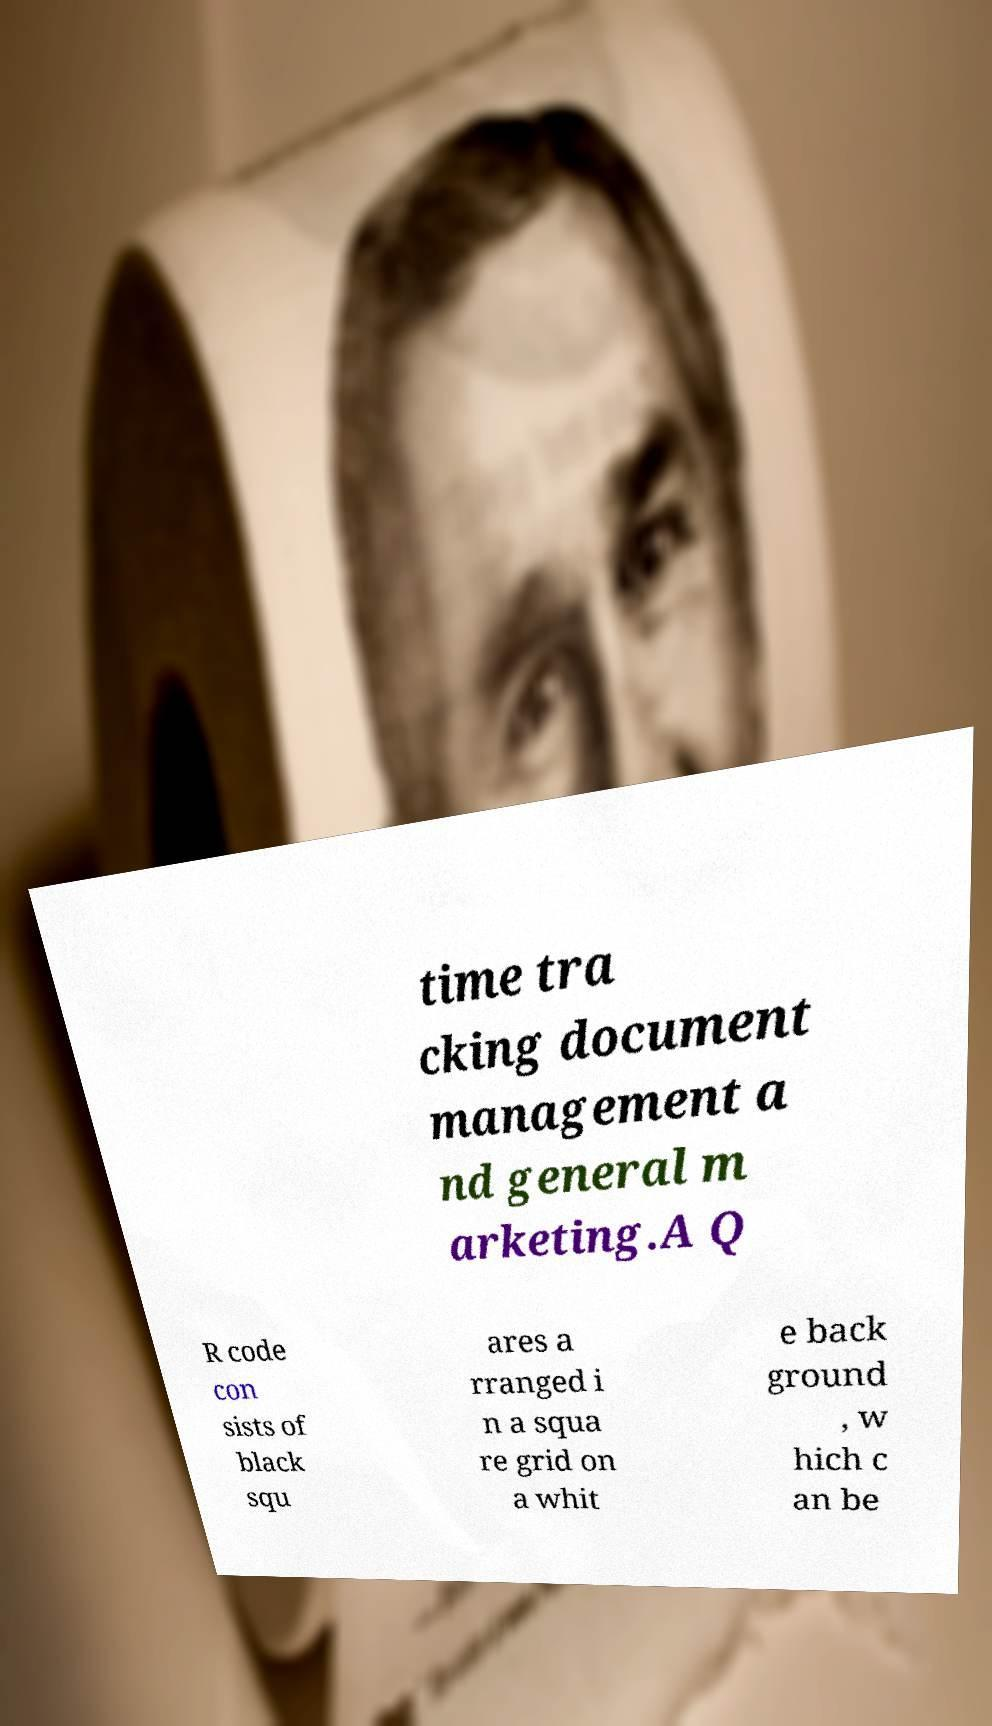Can you accurately transcribe the text from the provided image for me? time tra cking document management a nd general m arketing.A Q R code con sists of black squ ares a rranged i n a squa re grid on a whit e back ground , w hich c an be 